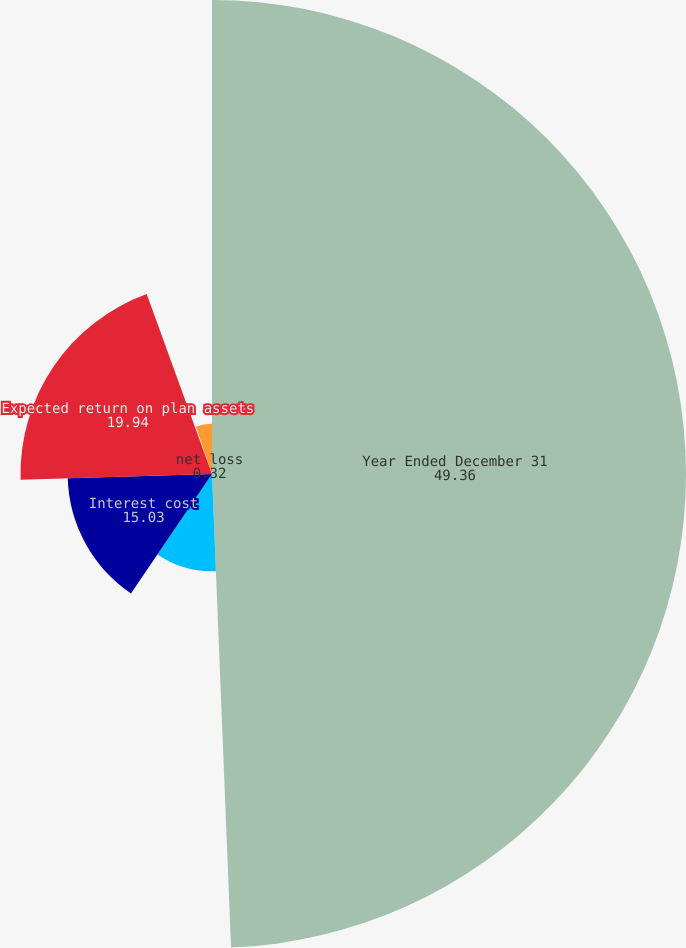<chart> <loc_0><loc_0><loc_500><loc_500><pie_chart><fcel>Year Ended December 31<fcel>Service cost<fcel>Interest cost<fcel>Expected return on plan assets<fcel>net loss<fcel>Net periodic benefit cost<nl><fcel>49.36%<fcel>10.13%<fcel>15.03%<fcel>19.94%<fcel>0.32%<fcel>5.22%<nl></chart> 